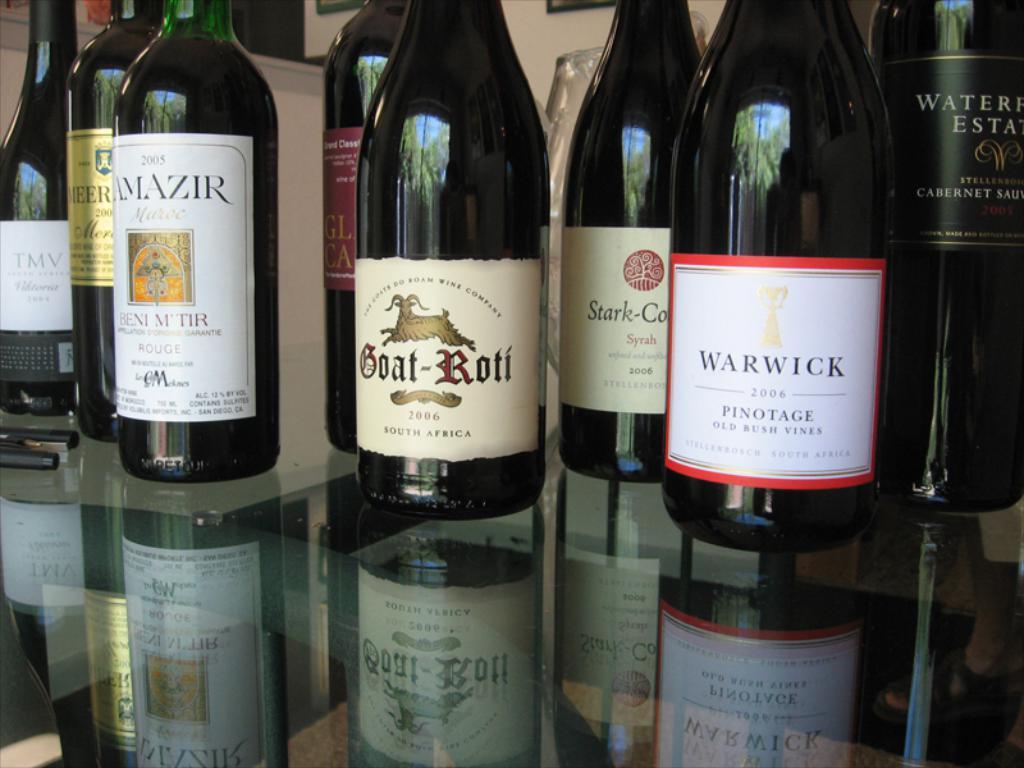What year was the amazir made in?
Give a very brief answer. 2005. 